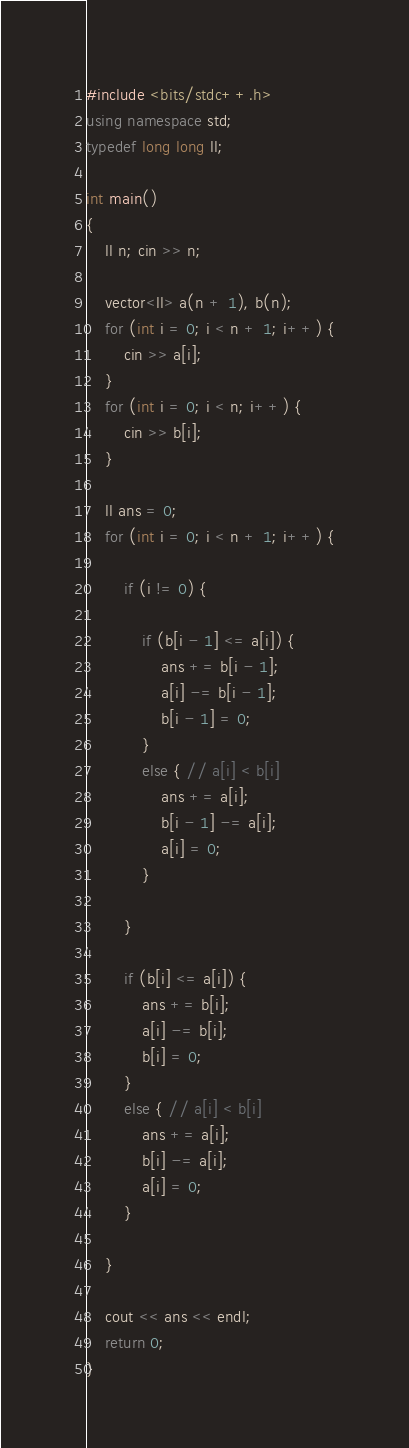<code> <loc_0><loc_0><loc_500><loc_500><_C++_>#include <bits/stdc++.h>
using namespace std;
typedef long long ll;

int main()
{
	ll n; cin >> n;

	vector<ll> a(n + 1), b(n);
	for (int i = 0; i < n + 1; i++) {
		cin >> a[i];
	}
	for (int i = 0; i < n; i++) {
		cin >> b[i];
	}
	
	ll ans = 0;
	for (int i = 0; i < n + 1; i++) {
		
		if (i != 0) {
	
			if (b[i - 1] <= a[i]) {
				ans += b[i - 1];
				a[i] -= b[i - 1];
				b[i - 1] = 0;				
			}
			else { // a[i] < b[i]
				ans += a[i];
				b[i - 1] -= a[i];
				a[i] = 0;
			}

		}
		
		if (b[i] <= a[i]) {
			ans += b[i];
			a[i] -= b[i];
			b[i] = 0;			
		}
		else { // a[i] < b[i]
			ans += a[i];
			b[i] -= a[i];
			a[i] = 0;			
		}

	}

	cout << ans << endl;
	return 0;
}</code> 